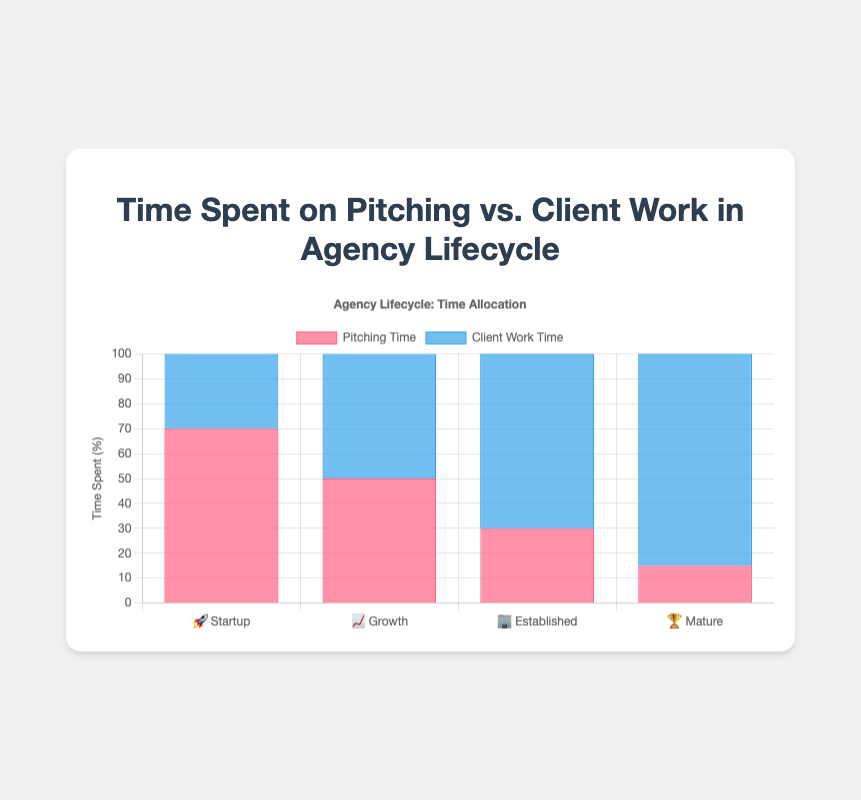How much time is spent on pitching during the Growth stage? The Growth stage has a bar for Pitching Time indicating 50%.
Answer: 50% What stage shows the highest amount of time spent on client work? The Mature stage has the tallest bar representing Client Work Time, which is 85%.
Answer: Mature Compare the time spent on pitching between the Startup and Established stages. The Startup stage shows 70% for pitching, while the Established stage shows 30%, so the Startup stage spends more time on pitching.
Answer: The Startup stage spends 40% more time on pitching than the Established stage What is the total time spent on mutual activities (pitching and client work) in the Startup stage? The Startup stage has 70% time spent on pitching and 30% on client work, summing up to 100%.
Answer: 100% Which stage indicates an equal proportion of time spent on pitching and client work? The Growth stage shows both pitching and client work at 50% each.
Answer: Growth In which stage is the time spent on pitching less than the time spent on client work? In the Established and Mature stages, the time spent on pitching is less than client work (30% vs 70% and 15% vs 85%, respectively).
Answer: Established and Mature How does the time allocation trend change as an agency progresses through its lifecycle? The time spent on pitching decreases (70% to 15%) while the time spent on client work increases (30% to 85%) from the Startup to the Mature stage.
Answer: Pitching decreases, client work increases Compare the time spent on client work between the Growth and Established stages and state the difference. The Growth stage has 50% and the Established stage has 70% time spent on client work, with a difference of 20%.
Answer: 20% Which stage has the least amount of pitching time and what is its value? The Mature stage shows the shortest bar for Pitching Time, which is 15%.
Answer: Mature, 15% Add the time spent on pitching and client work for the Established stage. What do you get? In the Established stage, 30% is spent on pitching and 70% on client work, adding up to 100%.
Answer: 100% 